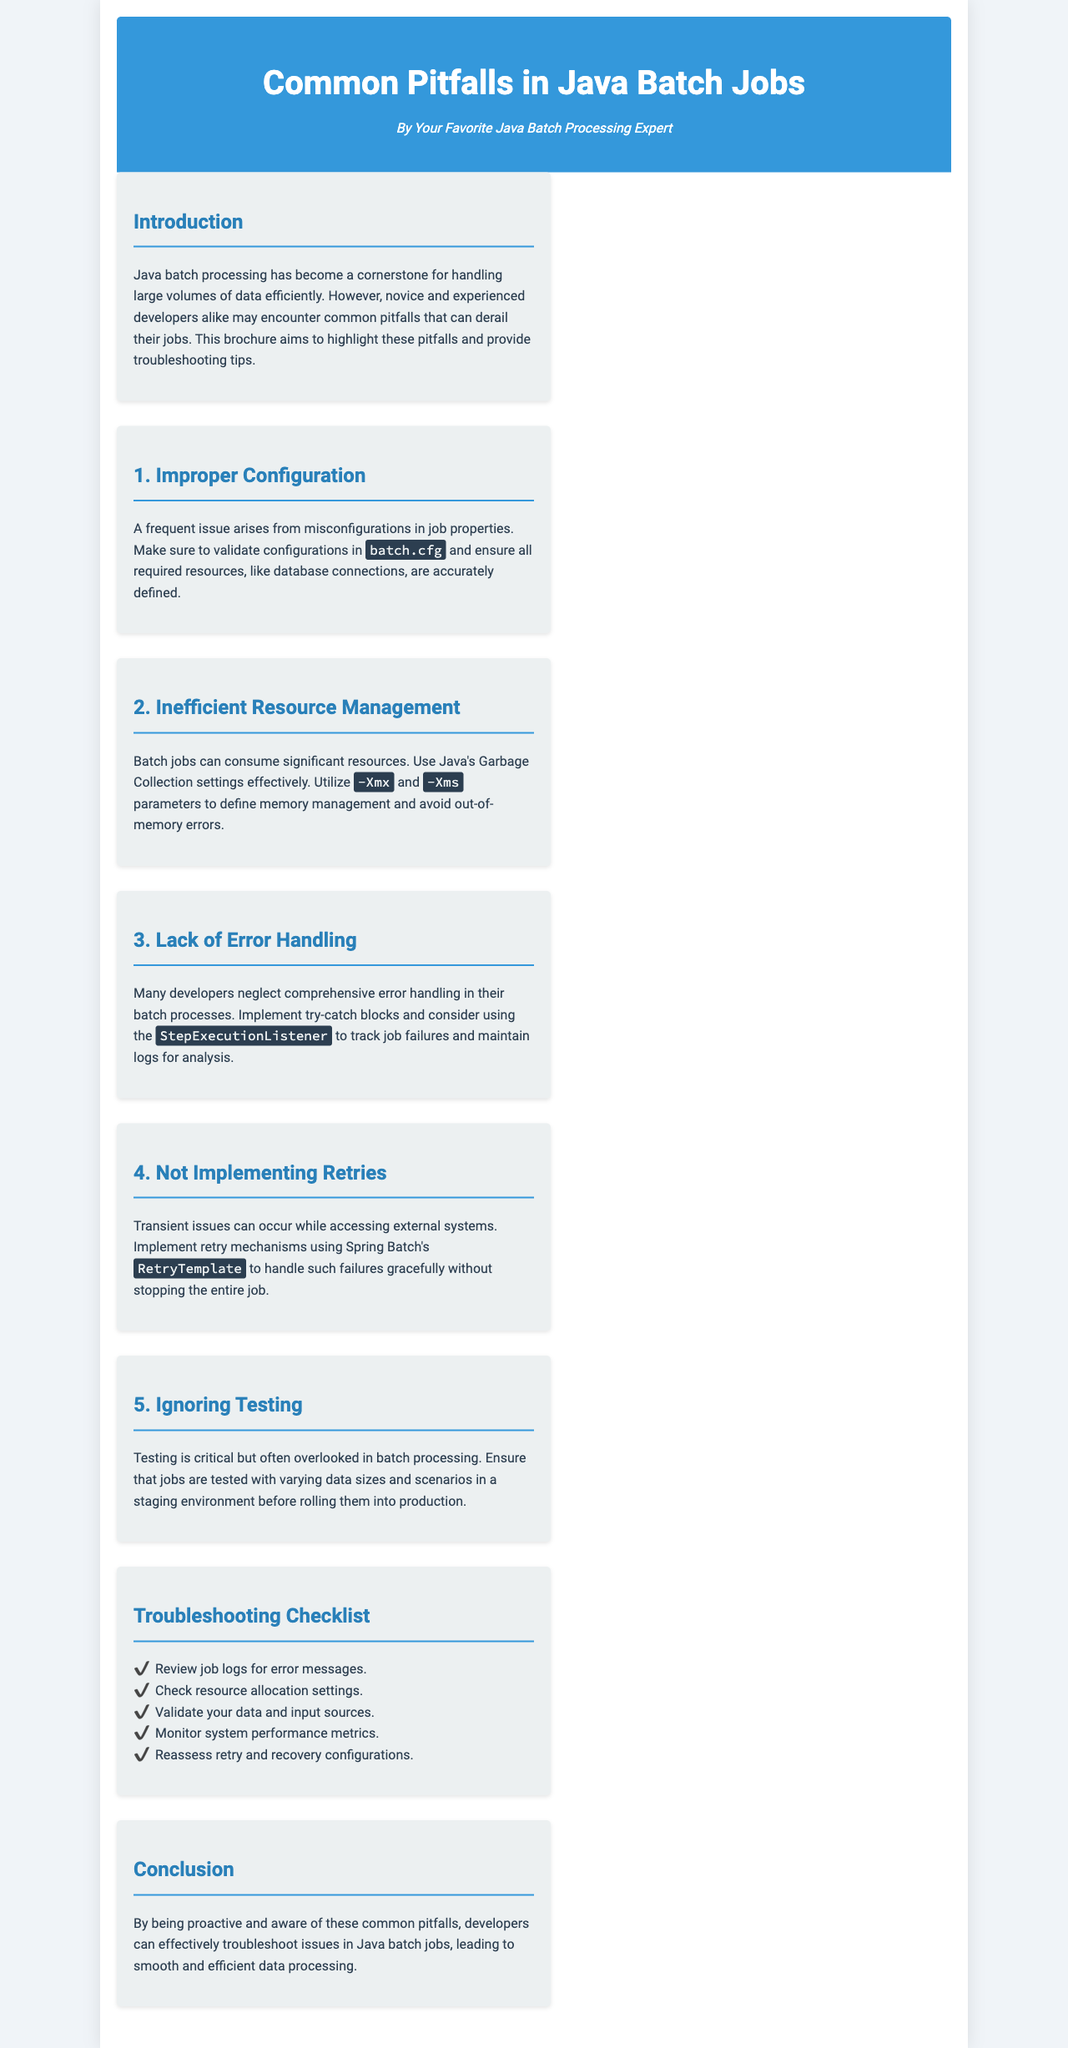What is the title of the brochure? The title is stated prominently at the top of the document.
Answer: Common Pitfalls in Java Batch Jobs Who is the author of the brochure? The author's name is mentioned under the title in the header section.
Answer: Your Favorite Java Batch Processing Expert What is a frequent issue in Java batch jobs? This is highlighted in the section discussing improper configuration.
Answer: Misconfigurations in job properties What are the parameters used for memory management? The document lists specific command-line options for Java memory settings.
Answer: -Xmx and -Xms What should developers implement to handle job failures? This is mentioned under the section on error handling.
Answer: Try-catch blocks Which mechanism can handle transient issues? This is explained in the section regarding retries in batch jobs.
Answer: RetryTemplate What is a critical step often overlooked in batch processing? It is noted as an essential task in the discussion on testing.
Answer: Testing What should you do to reassess configurations? This is part of the troubleshooting checklist provided in the document.
Answer: Check retry and recovery configurations What color is the header background? This is specified within the styling of the document.
Answer: Blue 